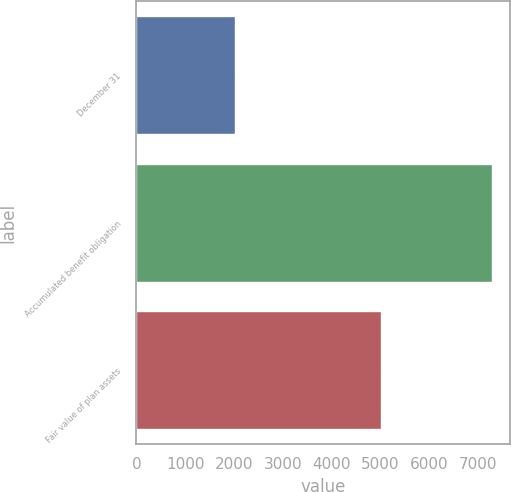Convert chart. <chart><loc_0><loc_0><loc_500><loc_500><bar_chart><fcel>December 31<fcel>Accumulated benefit obligation<fcel>Fair value of plan assets<nl><fcel>2011<fcel>7277<fcel>4998<nl></chart> 